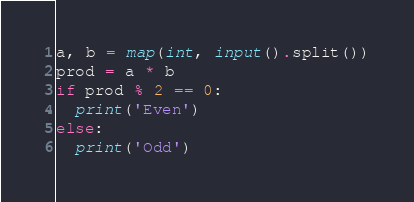<code> <loc_0><loc_0><loc_500><loc_500><_Python_>a, b = map(int, input().split())
prod = a * b
if prod % 2 == 0:
  print('Even')
else:
  print('Odd')</code> 